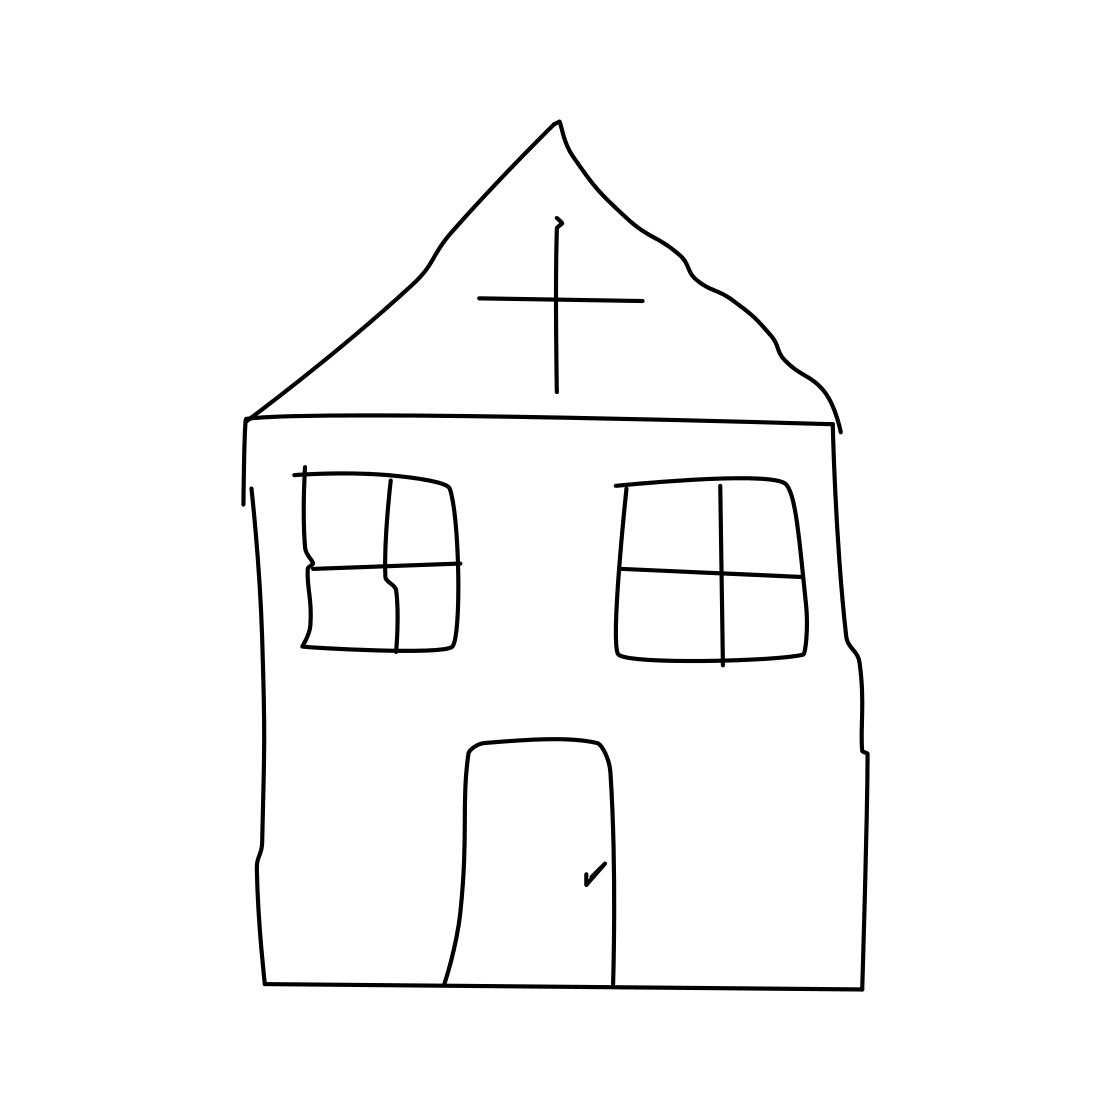Is there any symbolic meaning behind the cross on the roof in this sketch? The cross atop the church typically symbolizes faith and spirituality in Christian architecture. In this sketch, its prominent placement at the highest point of the roof emphasizes its significance, perhaps suggesting a focus on spiritual themes within this simplistic depiction. 